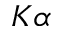<formula> <loc_0><loc_0><loc_500><loc_500>K \alpha</formula> 